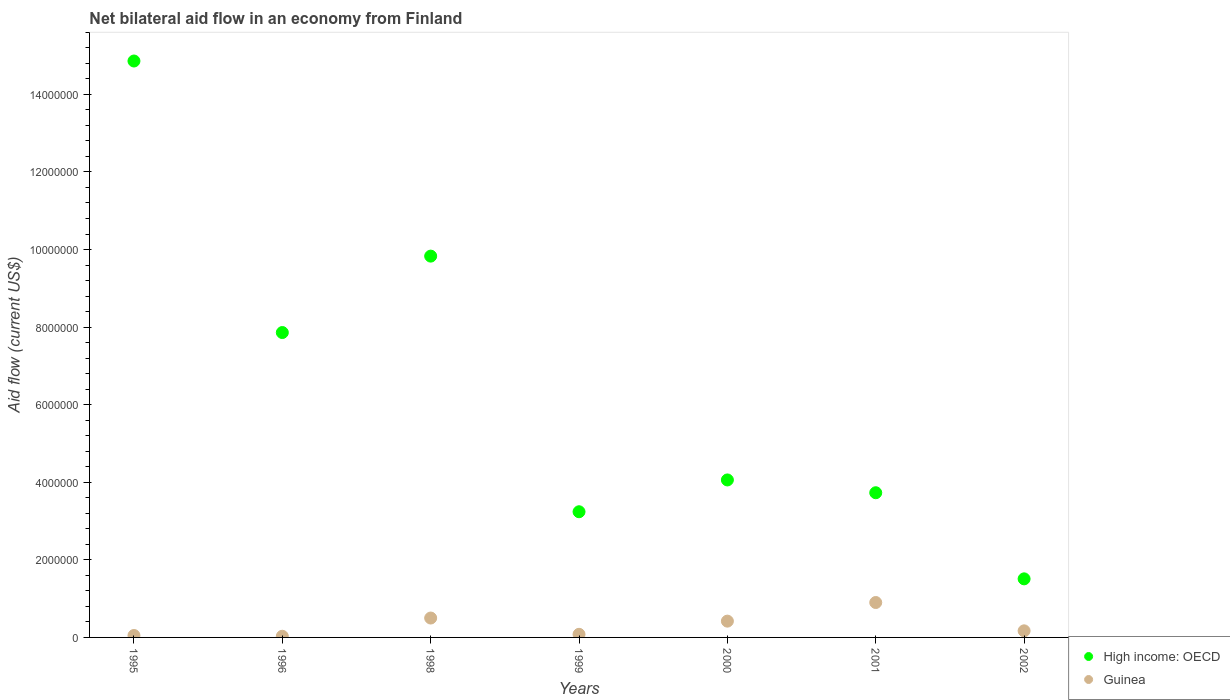How many different coloured dotlines are there?
Offer a terse response. 2. Is the number of dotlines equal to the number of legend labels?
Offer a very short reply. Yes. Across all years, what is the maximum net bilateral aid flow in High income: OECD?
Your answer should be compact. 1.49e+07. In which year was the net bilateral aid flow in High income: OECD minimum?
Offer a very short reply. 2002. What is the total net bilateral aid flow in High income: OECD in the graph?
Your answer should be compact. 4.51e+07. What is the average net bilateral aid flow in High income: OECD per year?
Your answer should be very brief. 6.44e+06. In the year 1998, what is the difference between the net bilateral aid flow in Guinea and net bilateral aid flow in High income: OECD?
Your answer should be very brief. -9.33e+06. What is the ratio of the net bilateral aid flow in Guinea in 1998 to that in 2000?
Make the answer very short. 1.19. Is the net bilateral aid flow in Guinea in 1998 less than that in 1999?
Ensure brevity in your answer.  No. What is the difference between the highest and the second highest net bilateral aid flow in Guinea?
Provide a short and direct response. 4.00e+05. What is the difference between the highest and the lowest net bilateral aid flow in High income: OECD?
Offer a terse response. 1.34e+07. Is the sum of the net bilateral aid flow in High income: OECD in 1996 and 1998 greater than the maximum net bilateral aid flow in Guinea across all years?
Offer a terse response. Yes. Does the net bilateral aid flow in High income: OECD monotonically increase over the years?
Give a very brief answer. No. Is the net bilateral aid flow in High income: OECD strictly greater than the net bilateral aid flow in Guinea over the years?
Provide a short and direct response. Yes. Is the net bilateral aid flow in High income: OECD strictly less than the net bilateral aid flow in Guinea over the years?
Make the answer very short. No. How many dotlines are there?
Your answer should be very brief. 2. How many years are there in the graph?
Give a very brief answer. 7. What is the difference between two consecutive major ticks on the Y-axis?
Make the answer very short. 2.00e+06. Are the values on the major ticks of Y-axis written in scientific E-notation?
Ensure brevity in your answer.  No. Does the graph contain any zero values?
Make the answer very short. No. What is the title of the graph?
Offer a very short reply. Net bilateral aid flow in an economy from Finland. Does "Cuba" appear as one of the legend labels in the graph?
Offer a very short reply. No. What is the label or title of the X-axis?
Your answer should be very brief. Years. What is the label or title of the Y-axis?
Provide a short and direct response. Aid flow (current US$). What is the Aid flow (current US$) in High income: OECD in 1995?
Your answer should be compact. 1.49e+07. What is the Aid flow (current US$) of Guinea in 1995?
Your answer should be compact. 5.00e+04. What is the Aid flow (current US$) in High income: OECD in 1996?
Your answer should be very brief. 7.86e+06. What is the Aid flow (current US$) in High income: OECD in 1998?
Your answer should be compact. 9.83e+06. What is the Aid flow (current US$) in Guinea in 1998?
Provide a succinct answer. 5.00e+05. What is the Aid flow (current US$) of High income: OECD in 1999?
Provide a succinct answer. 3.24e+06. What is the Aid flow (current US$) of High income: OECD in 2000?
Your response must be concise. 4.06e+06. What is the Aid flow (current US$) of Guinea in 2000?
Your answer should be very brief. 4.20e+05. What is the Aid flow (current US$) in High income: OECD in 2001?
Offer a terse response. 3.73e+06. What is the Aid flow (current US$) in High income: OECD in 2002?
Offer a terse response. 1.51e+06. Across all years, what is the maximum Aid flow (current US$) of High income: OECD?
Your answer should be very brief. 1.49e+07. Across all years, what is the minimum Aid flow (current US$) in High income: OECD?
Provide a short and direct response. 1.51e+06. Across all years, what is the minimum Aid flow (current US$) of Guinea?
Make the answer very short. 3.00e+04. What is the total Aid flow (current US$) of High income: OECD in the graph?
Your answer should be very brief. 4.51e+07. What is the total Aid flow (current US$) in Guinea in the graph?
Give a very brief answer. 2.15e+06. What is the difference between the Aid flow (current US$) of High income: OECD in 1995 and that in 1996?
Offer a very short reply. 7.00e+06. What is the difference between the Aid flow (current US$) in High income: OECD in 1995 and that in 1998?
Offer a very short reply. 5.03e+06. What is the difference between the Aid flow (current US$) of Guinea in 1995 and that in 1998?
Provide a succinct answer. -4.50e+05. What is the difference between the Aid flow (current US$) in High income: OECD in 1995 and that in 1999?
Keep it short and to the point. 1.16e+07. What is the difference between the Aid flow (current US$) of Guinea in 1995 and that in 1999?
Your response must be concise. -3.00e+04. What is the difference between the Aid flow (current US$) of High income: OECD in 1995 and that in 2000?
Offer a terse response. 1.08e+07. What is the difference between the Aid flow (current US$) of Guinea in 1995 and that in 2000?
Provide a succinct answer. -3.70e+05. What is the difference between the Aid flow (current US$) of High income: OECD in 1995 and that in 2001?
Give a very brief answer. 1.11e+07. What is the difference between the Aid flow (current US$) of Guinea in 1995 and that in 2001?
Your answer should be compact. -8.50e+05. What is the difference between the Aid flow (current US$) of High income: OECD in 1995 and that in 2002?
Provide a succinct answer. 1.34e+07. What is the difference between the Aid flow (current US$) of High income: OECD in 1996 and that in 1998?
Offer a very short reply. -1.97e+06. What is the difference between the Aid flow (current US$) in Guinea in 1996 and that in 1998?
Your answer should be compact. -4.70e+05. What is the difference between the Aid flow (current US$) in High income: OECD in 1996 and that in 1999?
Your answer should be compact. 4.62e+06. What is the difference between the Aid flow (current US$) of High income: OECD in 1996 and that in 2000?
Offer a very short reply. 3.80e+06. What is the difference between the Aid flow (current US$) in Guinea in 1996 and that in 2000?
Your answer should be very brief. -3.90e+05. What is the difference between the Aid flow (current US$) in High income: OECD in 1996 and that in 2001?
Your answer should be compact. 4.13e+06. What is the difference between the Aid flow (current US$) in Guinea in 1996 and that in 2001?
Give a very brief answer. -8.70e+05. What is the difference between the Aid flow (current US$) in High income: OECD in 1996 and that in 2002?
Make the answer very short. 6.35e+06. What is the difference between the Aid flow (current US$) of High income: OECD in 1998 and that in 1999?
Offer a very short reply. 6.59e+06. What is the difference between the Aid flow (current US$) of Guinea in 1998 and that in 1999?
Offer a very short reply. 4.20e+05. What is the difference between the Aid flow (current US$) in High income: OECD in 1998 and that in 2000?
Offer a terse response. 5.77e+06. What is the difference between the Aid flow (current US$) of High income: OECD in 1998 and that in 2001?
Provide a succinct answer. 6.10e+06. What is the difference between the Aid flow (current US$) in Guinea in 1998 and that in 2001?
Your answer should be compact. -4.00e+05. What is the difference between the Aid flow (current US$) in High income: OECD in 1998 and that in 2002?
Offer a terse response. 8.32e+06. What is the difference between the Aid flow (current US$) of High income: OECD in 1999 and that in 2000?
Your response must be concise. -8.20e+05. What is the difference between the Aid flow (current US$) of High income: OECD in 1999 and that in 2001?
Your answer should be very brief. -4.90e+05. What is the difference between the Aid flow (current US$) in Guinea in 1999 and that in 2001?
Give a very brief answer. -8.20e+05. What is the difference between the Aid flow (current US$) of High income: OECD in 1999 and that in 2002?
Your answer should be compact. 1.73e+06. What is the difference between the Aid flow (current US$) of High income: OECD in 2000 and that in 2001?
Provide a succinct answer. 3.30e+05. What is the difference between the Aid flow (current US$) in Guinea in 2000 and that in 2001?
Provide a succinct answer. -4.80e+05. What is the difference between the Aid flow (current US$) of High income: OECD in 2000 and that in 2002?
Provide a short and direct response. 2.55e+06. What is the difference between the Aid flow (current US$) of High income: OECD in 2001 and that in 2002?
Your response must be concise. 2.22e+06. What is the difference between the Aid flow (current US$) in Guinea in 2001 and that in 2002?
Make the answer very short. 7.30e+05. What is the difference between the Aid flow (current US$) of High income: OECD in 1995 and the Aid flow (current US$) of Guinea in 1996?
Make the answer very short. 1.48e+07. What is the difference between the Aid flow (current US$) in High income: OECD in 1995 and the Aid flow (current US$) in Guinea in 1998?
Offer a very short reply. 1.44e+07. What is the difference between the Aid flow (current US$) of High income: OECD in 1995 and the Aid flow (current US$) of Guinea in 1999?
Keep it short and to the point. 1.48e+07. What is the difference between the Aid flow (current US$) of High income: OECD in 1995 and the Aid flow (current US$) of Guinea in 2000?
Your answer should be very brief. 1.44e+07. What is the difference between the Aid flow (current US$) in High income: OECD in 1995 and the Aid flow (current US$) in Guinea in 2001?
Give a very brief answer. 1.40e+07. What is the difference between the Aid flow (current US$) of High income: OECD in 1995 and the Aid flow (current US$) of Guinea in 2002?
Give a very brief answer. 1.47e+07. What is the difference between the Aid flow (current US$) of High income: OECD in 1996 and the Aid flow (current US$) of Guinea in 1998?
Offer a very short reply. 7.36e+06. What is the difference between the Aid flow (current US$) of High income: OECD in 1996 and the Aid flow (current US$) of Guinea in 1999?
Your answer should be compact. 7.78e+06. What is the difference between the Aid flow (current US$) in High income: OECD in 1996 and the Aid flow (current US$) in Guinea in 2000?
Your response must be concise. 7.44e+06. What is the difference between the Aid flow (current US$) in High income: OECD in 1996 and the Aid flow (current US$) in Guinea in 2001?
Your answer should be very brief. 6.96e+06. What is the difference between the Aid flow (current US$) of High income: OECD in 1996 and the Aid flow (current US$) of Guinea in 2002?
Keep it short and to the point. 7.69e+06. What is the difference between the Aid flow (current US$) of High income: OECD in 1998 and the Aid flow (current US$) of Guinea in 1999?
Offer a very short reply. 9.75e+06. What is the difference between the Aid flow (current US$) of High income: OECD in 1998 and the Aid flow (current US$) of Guinea in 2000?
Keep it short and to the point. 9.41e+06. What is the difference between the Aid flow (current US$) in High income: OECD in 1998 and the Aid flow (current US$) in Guinea in 2001?
Your answer should be very brief. 8.93e+06. What is the difference between the Aid flow (current US$) of High income: OECD in 1998 and the Aid flow (current US$) of Guinea in 2002?
Ensure brevity in your answer.  9.66e+06. What is the difference between the Aid flow (current US$) in High income: OECD in 1999 and the Aid flow (current US$) in Guinea in 2000?
Your response must be concise. 2.82e+06. What is the difference between the Aid flow (current US$) of High income: OECD in 1999 and the Aid flow (current US$) of Guinea in 2001?
Your response must be concise. 2.34e+06. What is the difference between the Aid flow (current US$) in High income: OECD in 1999 and the Aid flow (current US$) in Guinea in 2002?
Your answer should be very brief. 3.07e+06. What is the difference between the Aid flow (current US$) in High income: OECD in 2000 and the Aid flow (current US$) in Guinea in 2001?
Keep it short and to the point. 3.16e+06. What is the difference between the Aid flow (current US$) of High income: OECD in 2000 and the Aid flow (current US$) of Guinea in 2002?
Your answer should be very brief. 3.89e+06. What is the difference between the Aid flow (current US$) of High income: OECD in 2001 and the Aid flow (current US$) of Guinea in 2002?
Make the answer very short. 3.56e+06. What is the average Aid flow (current US$) in High income: OECD per year?
Offer a very short reply. 6.44e+06. What is the average Aid flow (current US$) of Guinea per year?
Your response must be concise. 3.07e+05. In the year 1995, what is the difference between the Aid flow (current US$) of High income: OECD and Aid flow (current US$) of Guinea?
Provide a succinct answer. 1.48e+07. In the year 1996, what is the difference between the Aid flow (current US$) of High income: OECD and Aid flow (current US$) of Guinea?
Keep it short and to the point. 7.83e+06. In the year 1998, what is the difference between the Aid flow (current US$) in High income: OECD and Aid flow (current US$) in Guinea?
Keep it short and to the point. 9.33e+06. In the year 1999, what is the difference between the Aid flow (current US$) of High income: OECD and Aid flow (current US$) of Guinea?
Your response must be concise. 3.16e+06. In the year 2000, what is the difference between the Aid flow (current US$) in High income: OECD and Aid flow (current US$) in Guinea?
Offer a terse response. 3.64e+06. In the year 2001, what is the difference between the Aid flow (current US$) of High income: OECD and Aid flow (current US$) of Guinea?
Your response must be concise. 2.83e+06. In the year 2002, what is the difference between the Aid flow (current US$) of High income: OECD and Aid flow (current US$) of Guinea?
Ensure brevity in your answer.  1.34e+06. What is the ratio of the Aid flow (current US$) of High income: OECD in 1995 to that in 1996?
Offer a very short reply. 1.89. What is the ratio of the Aid flow (current US$) of High income: OECD in 1995 to that in 1998?
Make the answer very short. 1.51. What is the ratio of the Aid flow (current US$) in Guinea in 1995 to that in 1998?
Give a very brief answer. 0.1. What is the ratio of the Aid flow (current US$) in High income: OECD in 1995 to that in 1999?
Provide a short and direct response. 4.59. What is the ratio of the Aid flow (current US$) of Guinea in 1995 to that in 1999?
Give a very brief answer. 0.62. What is the ratio of the Aid flow (current US$) in High income: OECD in 1995 to that in 2000?
Offer a terse response. 3.66. What is the ratio of the Aid flow (current US$) in Guinea in 1995 to that in 2000?
Your response must be concise. 0.12. What is the ratio of the Aid flow (current US$) of High income: OECD in 1995 to that in 2001?
Your answer should be very brief. 3.98. What is the ratio of the Aid flow (current US$) in Guinea in 1995 to that in 2001?
Your answer should be compact. 0.06. What is the ratio of the Aid flow (current US$) of High income: OECD in 1995 to that in 2002?
Provide a succinct answer. 9.84. What is the ratio of the Aid flow (current US$) of Guinea in 1995 to that in 2002?
Provide a short and direct response. 0.29. What is the ratio of the Aid flow (current US$) of High income: OECD in 1996 to that in 1998?
Offer a very short reply. 0.8. What is the ratio of the Aid flow (current US$) of High income: OECD in 1996 to that in 1999?
Offer a very short reply. 2.43. What is the ratio of the Aid flow (current US$) in High income: OECD in 1996 to that in 2000?
Offer a terse response. 1.94. What is the ratio of the Aid flow (current US$) in Guinea in 1996 to that in 2000?
Offer a terse response. 0.07. What is the ratio of the Aid flow (current US$) in High income: OECD in 1996 to that in 2001?
Offer a very short reply. 2.11. What is the ratio of the Aid flow (current US$) in Guinea in 1996 to that in 2001?
Give a very brief answer. 0.03. What is the ratio of the Aid flow (current US$) of High income: OECD in 1996 to that in 2002?
Offer a terse response. 5.21. What is the ratio of the Aid flow (current US$) of Guinea in 1996 to that in 2002?
Give a very brief answer. 0.18. What is the ratio of the Aid flow (current US$) of High income: OECD in 1998 to that in 1999?
Your answer should be very brief. 3.03. What is the ratio of the Aid flow (current US$) in Guinea in 1998 to that in 1999?
Your answer should be very brief. 6.25. What is the ratio of the Aid flow (current US$) in High income: OECD in 1998 to that in 2000?
Ensure brevity in your answer.  2.42. What is the ratio of the Aid flow (current US$) of Guinea in 1998 to that in 2000?
Provide a succinct answer. 1.19. What is the ratio of the Aid flow (current US$) in High income: OECD in 1998 to that in 2001?
Make the answer very short. 2.64. What is the ratio of the Aid flow (current US$) of Guinea in 1998 to that in 2001?
Ensure brevity in your answer.  0.56. What is the ratio of the Aid flow (current US$) in High income: OECD in 1998 to that in 2002?
Offer a very short reply. 6.51. What is the ratio of the Aid flow (current US$) of Guinea in 1998 to that in 2002?
Make the answer very short. 2.94. What is the ratio of the Aid flow (current US$) of High income: OECD in 1999 to that in 2000?
Offer a very short reply. 0.8. What is the ratio of the Aid flow (current US$) in Guinea in 1999 to that in 2000?
Your response must be concise. 0.19. What is the ratio of the Aid flow (current US$) in High income: OECD in 1999 to that in 2001?
Offer a very short reply. 0.87. What is the ratio of the Aid flow (current US$) of Guinea in 1999 to that in 2001?
Make the answer very short. 0.09. What is the ratio of the Aid flow (current US$) in High income: OECD in 1999 to that in 2002?
Provide a succinct answer. 2.15. What is the ratio of the Aid flow (current US$) in Guinea in 1999 to that in 2002?
Keep it short and to the point. 0.47. What is the ratio of the Aid flow (current US$) in High income: OECD in 2000 to that in 2001?
Your answer should be compact. 1.09. What is the ratio of the Aid flow (current US$) of Guinea in 2000 to that in 2001?
Your answer should be compact. 0.47. What is the ratio of the Aid flow (current US$) in High income: OECD in 2000 to that in 2002?
Make the answer very short. 2.69. What is the ratio of the Aid flow (current US$) in Guinea in 2000 to that in 2002?
Keep it short and to the point. 2.47. What is the ratio of the Aid flow (current US$) in High income: OECD in 2001 to that in 2002?
Offer a terse response. 2.47. What is the ratio of the Aid flow (current US$) of Guinea in 2001 to that in 2002?
Offer a very short reply. 5.29. What is the difference between the highest and the second highest Aid flow (current US$) in High income: OECD?
Offer a very short reply. 5.03e+06. What is the difference between the highest and the second highest Aid flow (current US$) in Guinea?
Provide a short and direct response. 4.00e+05. What is the difference between the highest and the lowest Aid flow (current US$) of High income: OECD?
Provide a short and direct response. 1.34e+07. What is the difference between the highest and the lowest Aid flow (current US$) in Guinea?
Your answer should be very brief. 8.70e+05. 